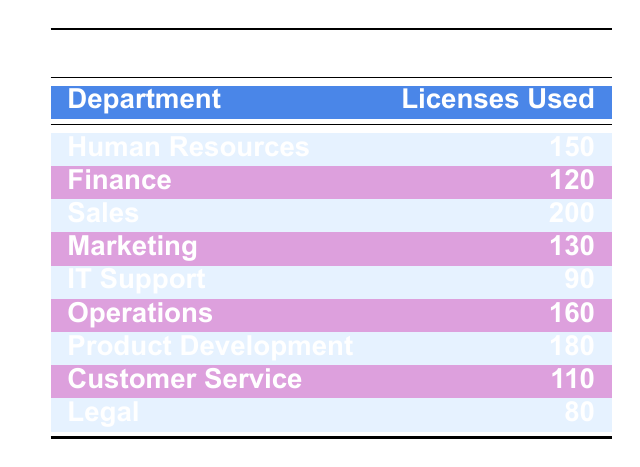What department uses the most software licenses? By looking at the "Licenses Used" column, we see that the "Sales" department has the highest value at 200.
Answer: Sales How many software licenses does the Legal department use? The "Licenses Used" column shows that the "Legal" department has 80 licenses.
Answer: 80 What is the total number of software licenses used by the IT Support and Customer Service departments combined? We look at the "Licenses Used" for IT Support (90) and Customer Service (110). Adding these gives 90 + 110 = 200.
Answer: 200 Is the number of licenses used by the Marketing department more than that of the Finance department? The "Licenses Used" column indicates that Marketing uses 130 licenses while Finance uses 120. Since 130 is greater than 120, the statement is true.
Answer: Yes What is the average number of software licenses used across all departments? First, we total the licenses for all departments: 150 + 120 + 200 + 130 + 90 + 160 + 180 + 110 + 80 = 1,120. There are 9 departments, so we divide 1,120 by 9, which results in approximately 124.44.
Answer: 124.44 Which department uses fewer licenses, Finance or Customer Service? The licenses used are 120 for Finance and 110 for Customer Service. Since 110 is less than 120, Customer Service uses fewer licenses.
Answer: Customer Service What is the difference in the number of software licenses used between the Sales and Legal departments? We have 200 licenses for Sales and 80 for Legal. The difference is calculated as 200 - 80 = 120.
Answer: 120 How many departments use more than 150 licenses? Referring to the table, we count the departments: Sales (200), Operations (160), and Product Development (180). There are three departments that use more than 150 licenses.
Answer: 3 Does the Operations department use the least number of licenses? The Operations department has 160 licenses, while the Legal department uses 80, making Legal the one with the least. Therefore, the statement is false.
Answer: No 